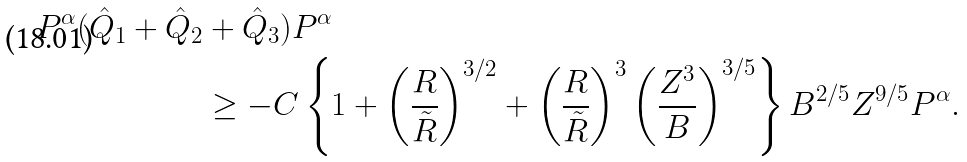Convert formula to latex. <formula><loc_0><loc_0><loc_500><loc_500>P ^ { \alpha } ( \hat { Q } _ { 1 } + \hat { Q } _ { 2 } & + \hat { Q } _ { 3 } ) P ^ { \alpha } \\ & \geq - C \left \{ 1 + \left ( \frac { R } { \tilde { R } } \right ) ^ { 3 / 2 } + \left ( \frac { R } { \tilde { R } } \right ) ^ { 3 } \left ( \frac { Z ^ { 3 } } { B } \right ) ^ { 3 / 5 } \right \} B ^ { 2 / 5 } Z ^ { 9 / 5 } P ^ { \alpha } .</formula> 